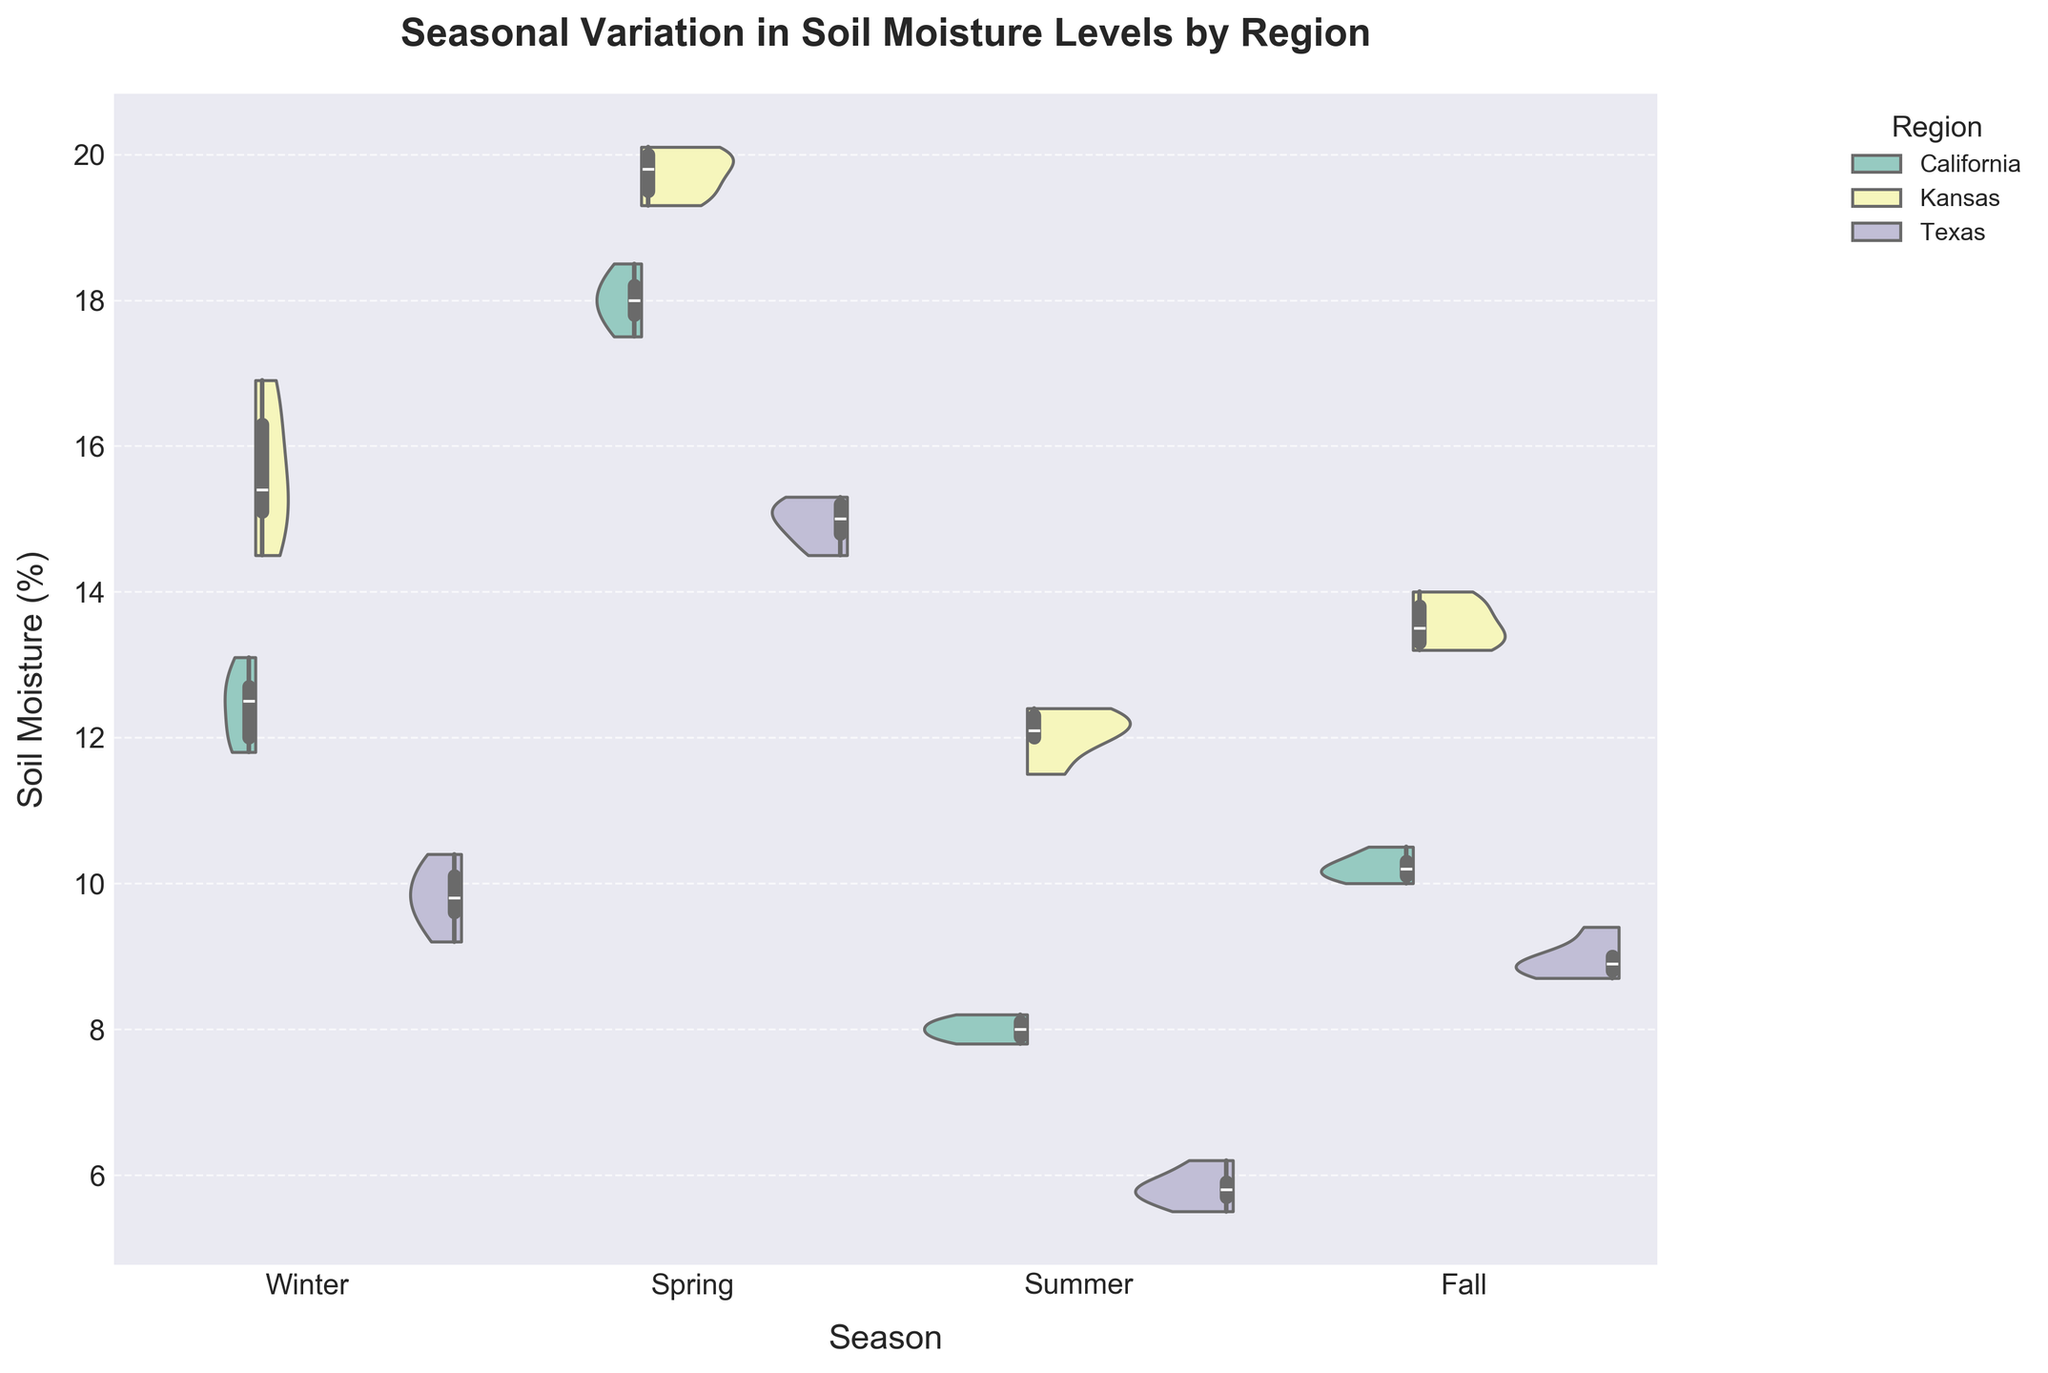What is the title of the figure? The title of the figure is displayed at the top and provides an overview of the data being visualized. It reads "Seasonal Variation in Soil Moisture Levels by Region"
Answer: Seasonal Variation in Soil Moisture Levels by Region Which season has the highest median soil moisture in California? To determine this, we look at the box plot overlay within the violin plot for California in each season. The line in the center of the box represents the median. By comparing this line across all seasons, we observe that Spring has the highest median soil moisture.
Answer: Spring How does soil moisture in Kansas during Summer compare to that in California during Summer? Comparing the violin plots for Kansas and California during Summer helps us see the general distribution of soil moisture. Kansas has a higher range of soil moisture levels compared to California, as shown by both the wider violin plot and the higher box plot.
Answer: Higher in Kansas What is the range of soil moisture levels in Texas during Winter? The range can be determined by looking at the full spread of the violin plot and box plot for Texas in Winter. The minimum and maximum values from the box plot give us the range: approximately 9.2% to 10.4%.
Answer: 9.2% to 10.4% During which season does Texas display the lowest soil moisture levels? By comparing the distributions in the violin plots for Texas across all seasons, Summer shows the lowest soil moisture levels. The Summer violin plot is positioned lower on the y-axis compared to other seasons.
Answer: Summer Which region exhibits the most variability in soil moisture during Fall? Variability can be observed through the spread of the violin plot and the interquartile range in the box plot. For Fall, Kansas exhibits the most variability as it has the widest violin plot and largest box plot range.
Answer: Kansas 